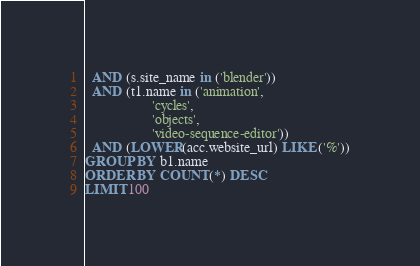Convert code to text. <code><loc_0><loc_0><loc_500><loc_500><_SQL_>  AND (s.site_name in ('blender'))
  AND (t1.name in ('animation',
                   'cycles',
                   'objects',
                   'video-sequence-editor'))
  AND (LOWER(acc.website_url) LIKE ('%'))
GROUP BY b1.name
ORDER BY COUNT(*) DESC
LIMIT 100</code> 